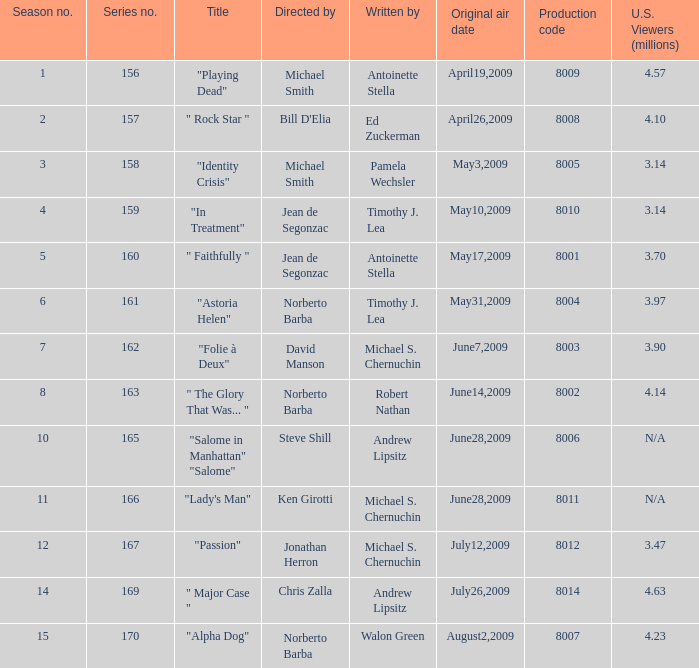Who are the writer of the series episode number 170? Walon Green. 